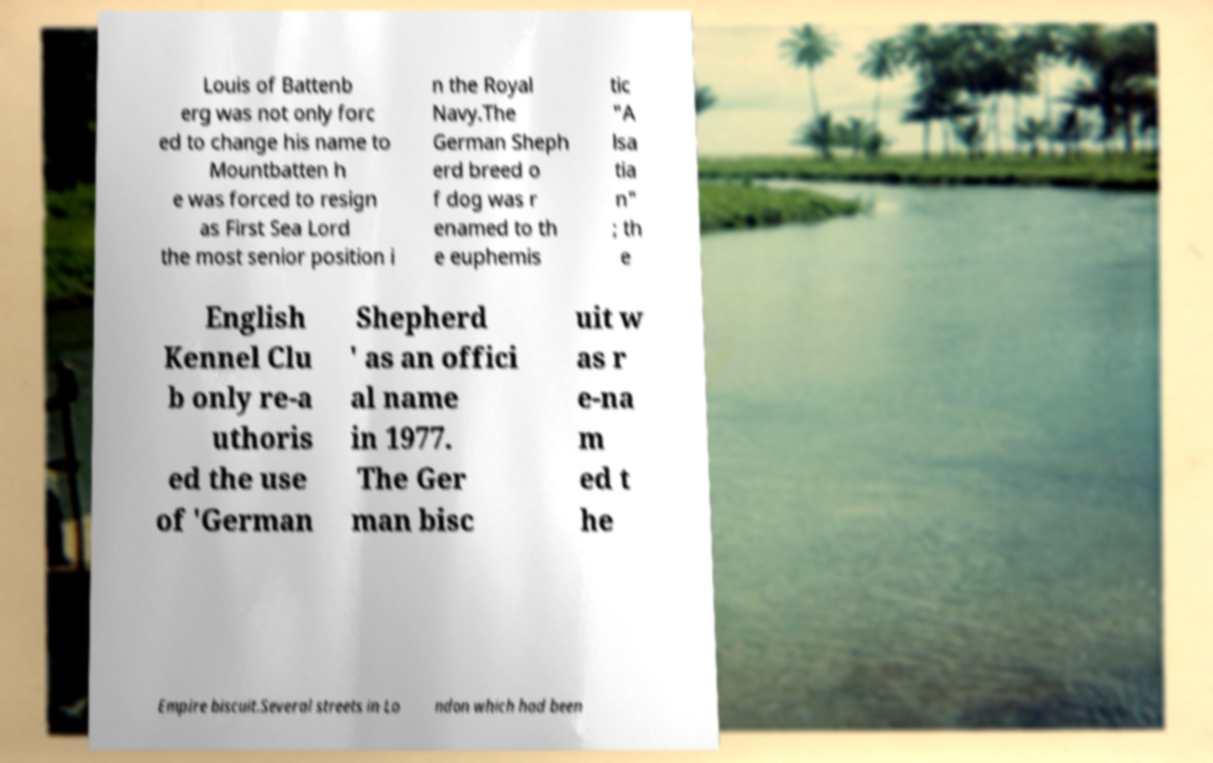Can you accurately transcribe the text from the provided image for me? Louis of Battenb erg was not only forc ed to change his name to Mountbatten h e was forced to resign as First Sea Lord the most senior position i n the Royal Navy.The German Sheph erd breed o f dog was r enamed to th e euphemis tic "A lsa tia n" ; th e English Kennel Clu b only re-a uthoris ed the use of 'German Shepherd ' as an offici al name in 1977. The Ger man bisc uit w as r e-na m ed t he Empire biscuit.Several streets in Lo ndon which had been 